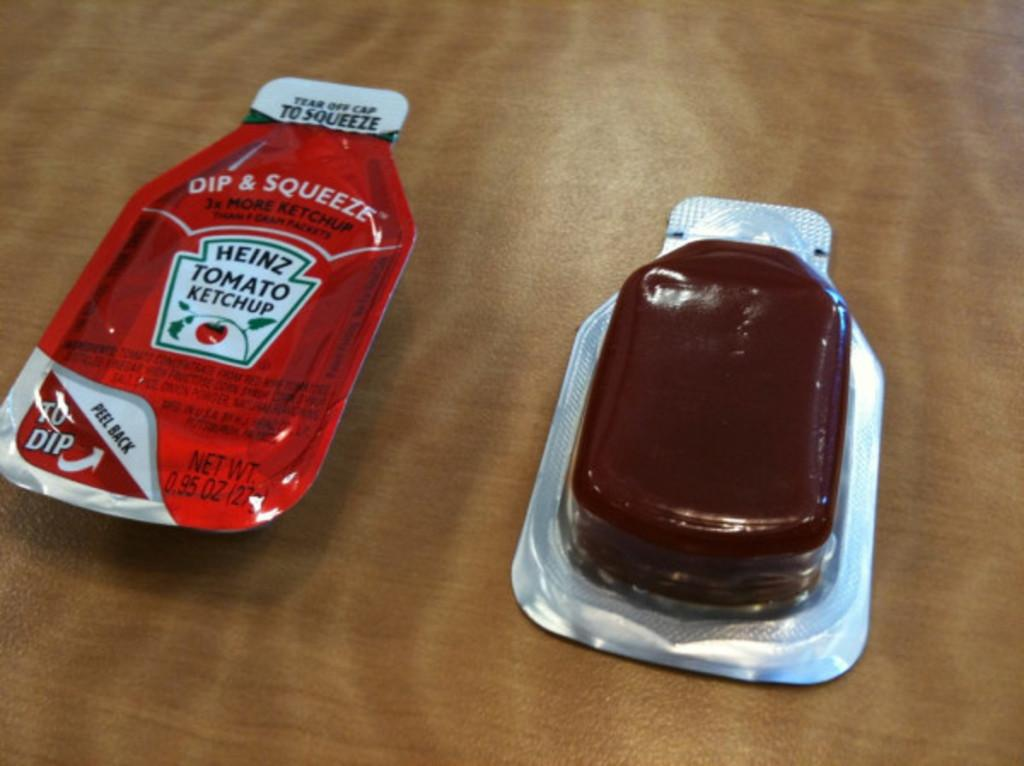<image>
Summarize the visual content of the image. two small packets of dip & squeeze heinz tomato ketchup 